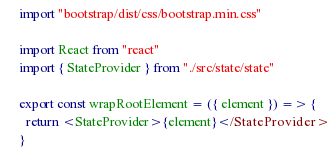<code> <loc_0><loc_0><loc_500><loc_500><_JavaScript_>import "bootstrap/dist/css/bootstrap.min.css"

import React from "react"
import { StateProvider } from "./src/state/state"

export const wrapRootElement = ({ element }) => {
  return <StateProvider>{element}</StateProvider>
}
</code> 